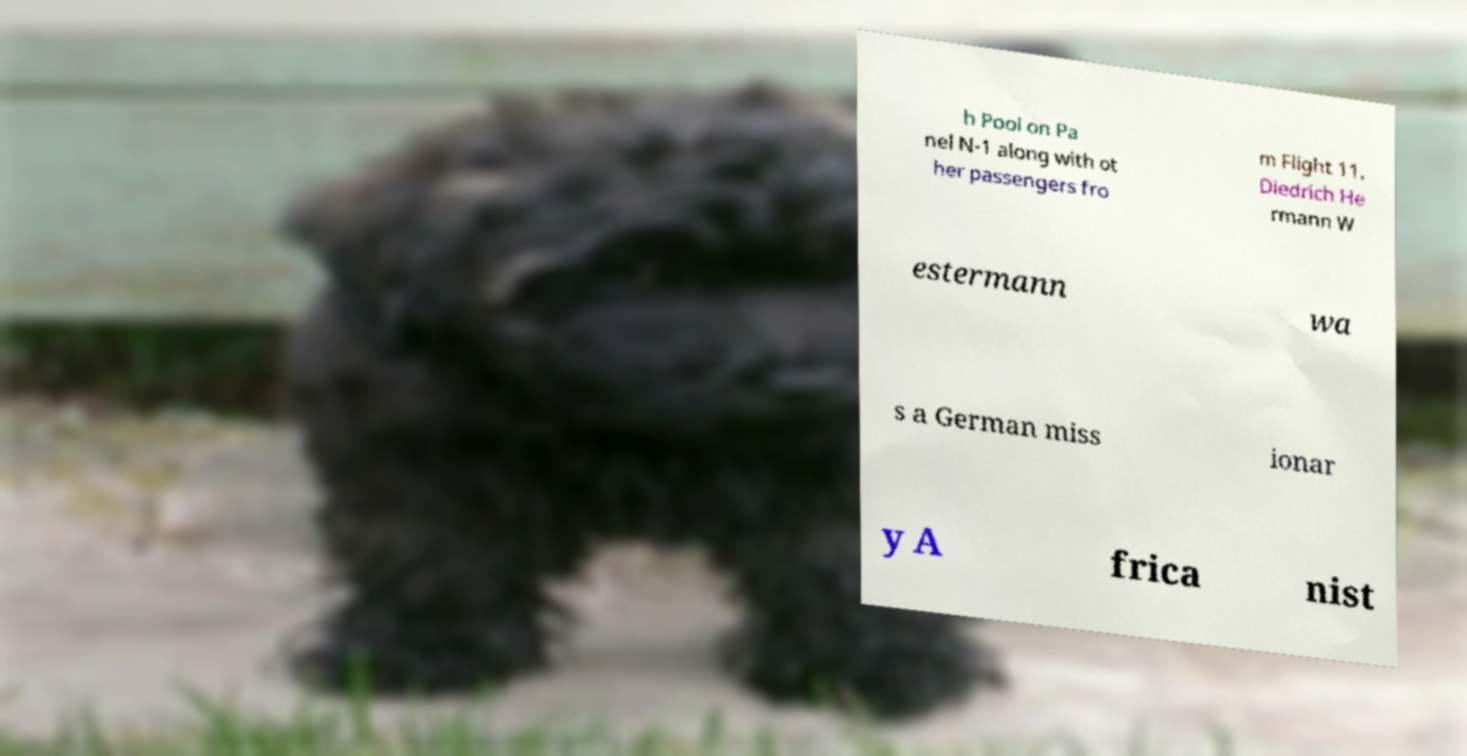Can you read and provide the text displayed in the image?This photo seems to have some interesting text. Can you extract and type it out for me? h Pool on Pa nel N-1 along with ot her passengers fro m Flight 11. Diedrich He rmann W estermann wa s a German miss ionar y A frica nist 